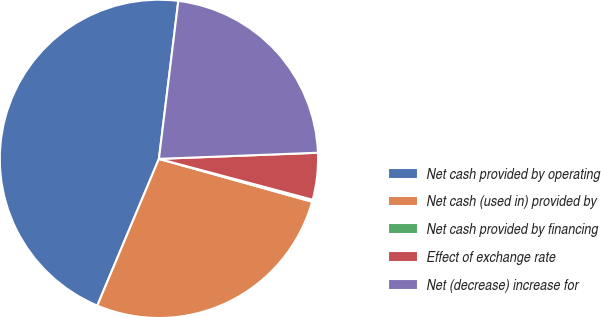Convert chart. <chart><loc_0><loc_0><loc_500><loc_500><pie_chart><fcel>Net cash provided by operating<fcel>Net cash (used in) provided by<fcel>Net cash provided by financing<fcel>Effect of exchange rate<fcel>Net (decrease) increase for<nl><fcel>45.61%<fcel>26.98%<fcel>0.21%<fcel>4.75%<fcel>22.44%<nl></chart> 